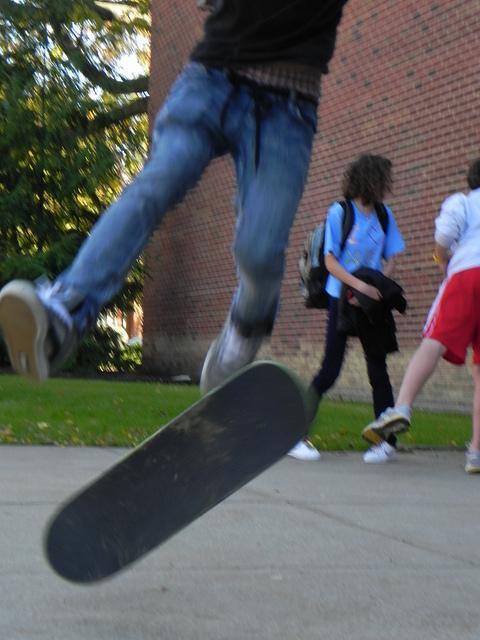How many untied shoelaces are visible?
Give a very brief answer. 0. How many people are there?
Give a very brief answer. 3. How many skateboards can be seen?
Give a very brief answer. 1. 